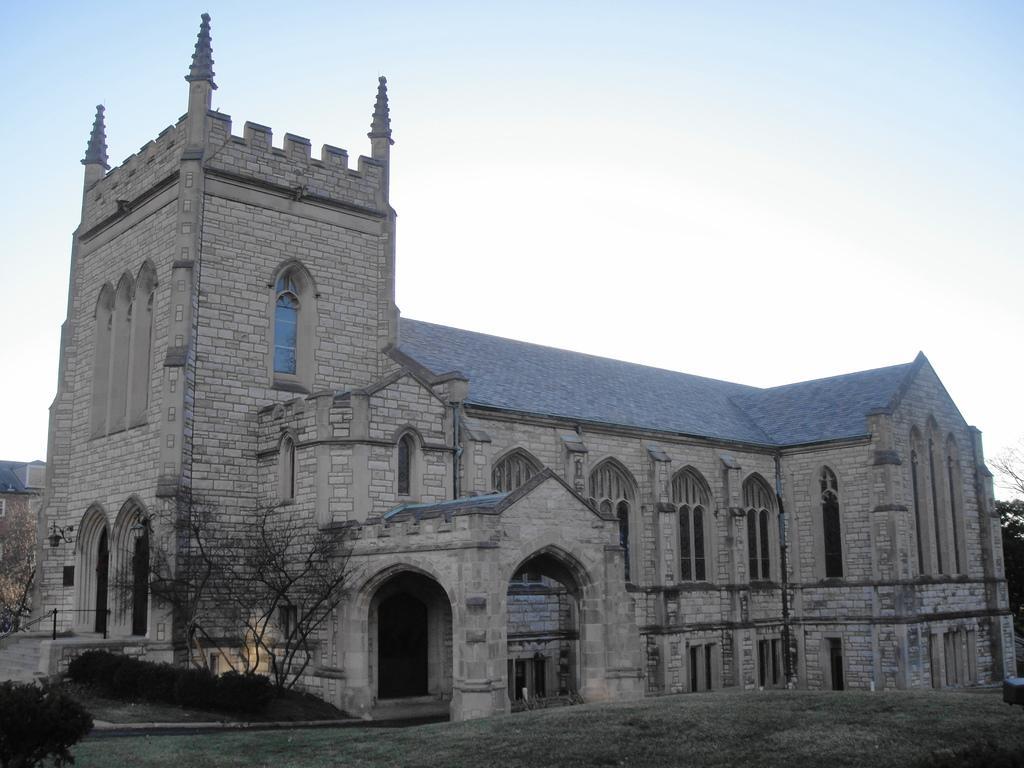Can you describe this image briefly? In this image there is a big building in-front of that there are some plants, small trees and grass on the ground. 